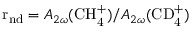Convert formula to latex. <formula><loc_0><loc_0><loc_500><loc_500>r _ { n d } = A _ { 2 \omega } ( C H _ { 4 } ^ { + } ) / A _ { 2 \omega } ( C D _ { 4 } ^ { + } )</formula> 